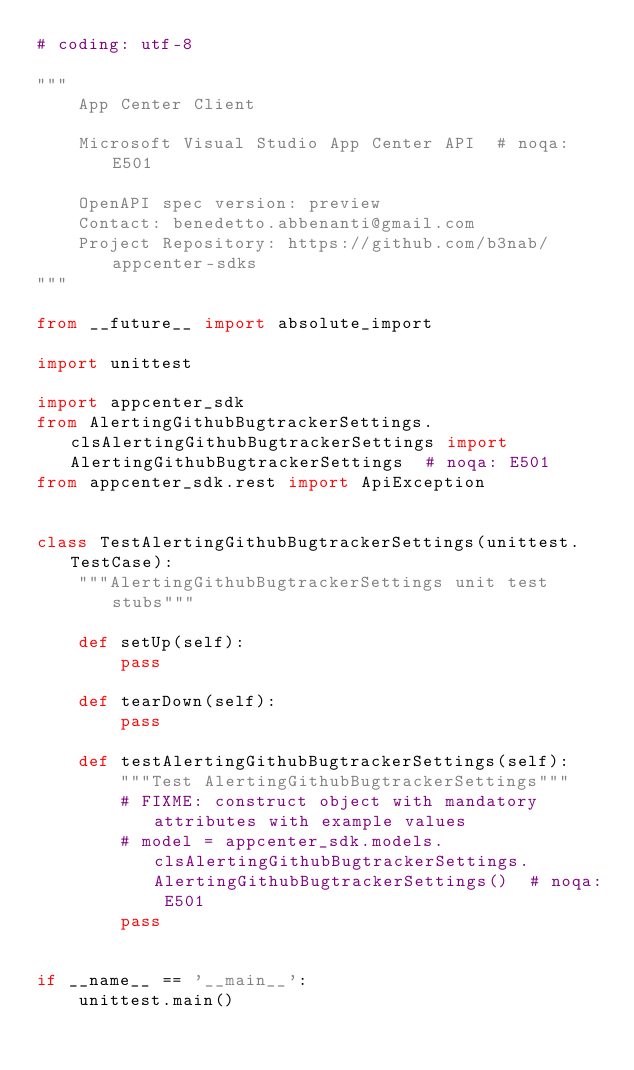Convert code to text. <code><loc_0><loc_0><loc_500><loc_500><_Python_># coding: utf-8

"""
    App Center Client

    Microsoft Visual Studio App Center API  # noqa: E501

    OpenAPI spec version: preview
    Contact: benedetto.abbenanti@gmail.com
    Project Repository: https://github.com/b3nab/appcenter-sdks
"""

from __future__ import absolute_import

import unittest

import appcenter_sdk
from AlertingGithubBugtrackerSettings.clsAlertingGithubBugtrackerSettings import AlertingGithubBugtrackerSettings  # noqa: E501
from appcenter_sdk.rest import ApiException


class TestAlertingGithubBugtrackerSettings(unittest.TestCase):
    """AlertingGithubBugtrackerSettings unit test stubs"""

    def setUp(self):
        pass

    def tearDown(self):
        pass

    def testAlertingGithubBugtrackerSettings(self):
        """Test AlertingGithubBugtrackerSettings"""
        # FIXME: construct object with mandatory attributes with example values
        # model = appcenter_sdk.models.clsAlertingGithubBugtrackerSettings.AlertingGithubBugtrackerSettings()  # noqa: E501
        pass


if __name__ == '__main__':
    unittest.main()
</code> 